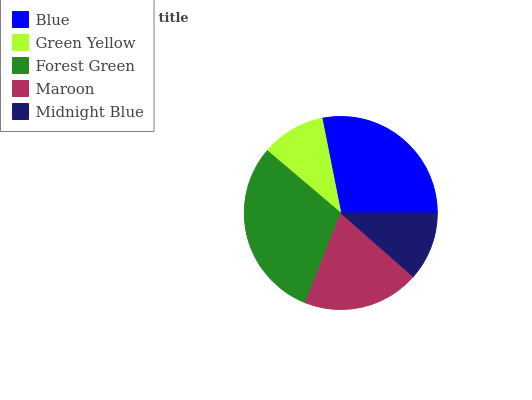Is Green Yellow the minimum?
Answer yes or no. Yes. Is Forest Green the maximum?
Answer yes or no. Yes. Is Forest Green the minimum?
Answer yes or no. No. Is Green Yellow the maximum?
Answer yes or no. No. Is Forest Green greater than Green Yellow?
Answer yes or no. Yes. Is Green Yellow less than Forest Green?
Answer yes or no. Yes. Is Green Yellow greater than Forest Green?
Answer yes or no. No. Is Forest Green less than Green Yellow?
Answer yes or no. No. Is Maroon the high median?
Answer yes or no. Yes. Is Maroon the low median?
Answer yes or no. Yes. Is Forest Green the high median?
Answer yes or no. No. Is Forest Green the low median?
Answer yes or no. No. 